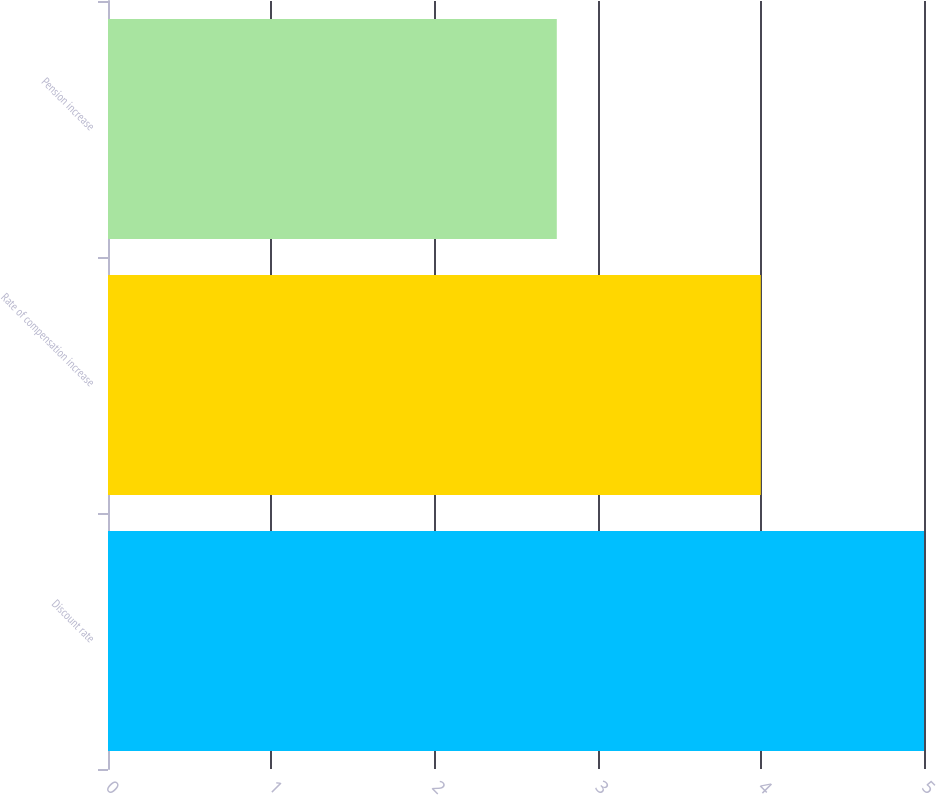Convert chart to OTSL. <chart><loc_0><loc_0><loc_500><loc_500><bar_chart><fcel>Discount rate<fcel>Rate of compensation increase<fcel>Pension increase<nl><fcel>5<fcel>4<fcel>2.75<nl></chart> 